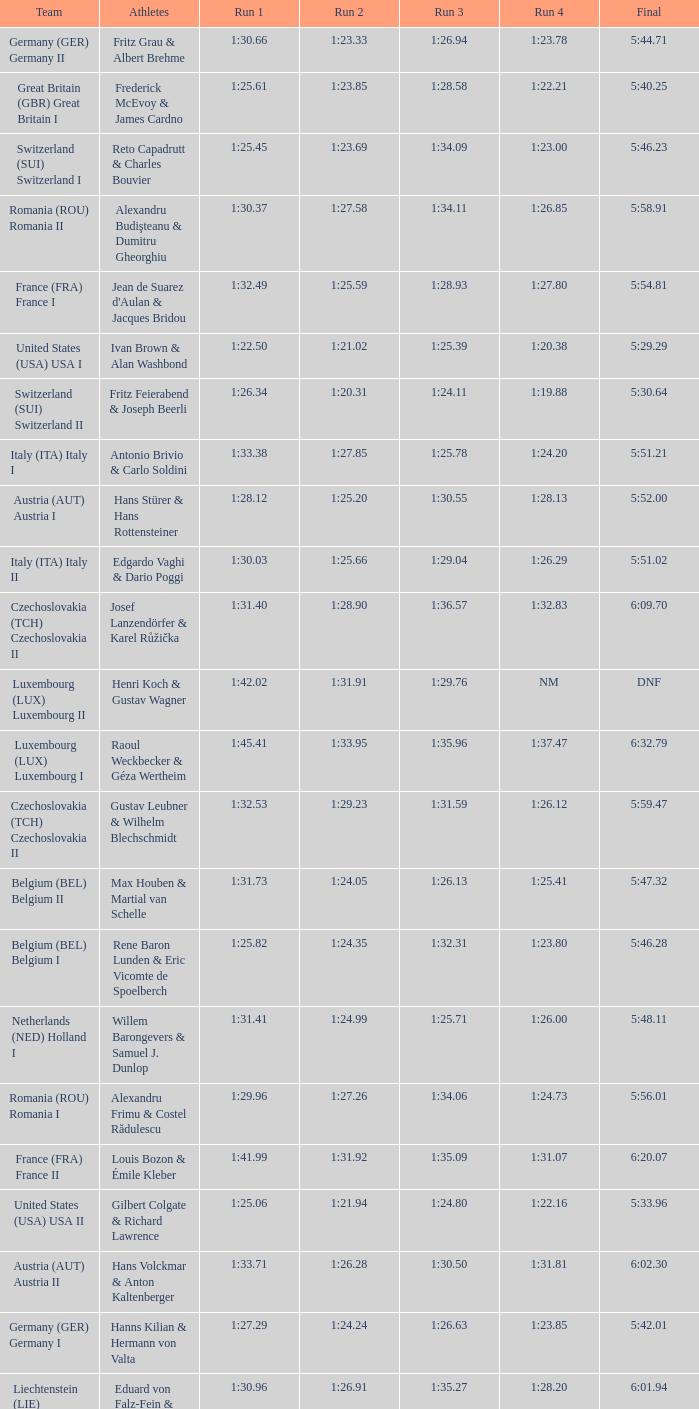Which Run 4 has a Run 1 of 1:25.82? 1:23.80. 